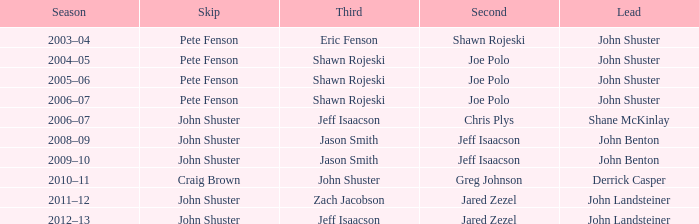Who was the lead with Pete Fenson as skip and Joe Polo as second in season 2005–06? John Shuster. 